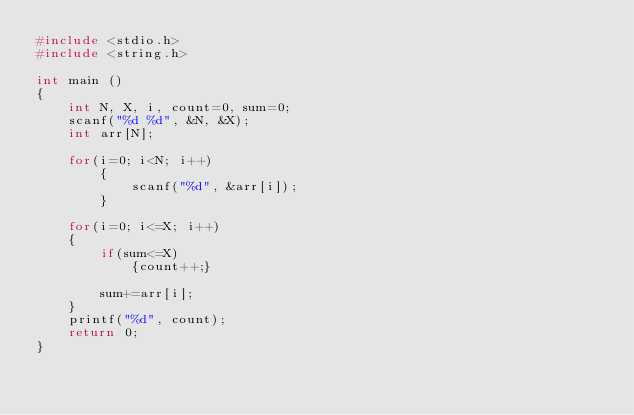Convert code to text. <code><loc_0><loc_0><loc_500><loc_500><_C_>#include <stdio.h>
#include <string.h>

int main ()
{
    int N, X, i, count=0, sum=0;
    scanf("%d %d", &N, &X);
    int arr[N];

    for(i=0; i<N; i++)
        {
            scanf("%d", &arr[i]);
        }

    for(i=0; i<=X; i++)
    {
        if(sum<=X)
            {count++;}

        sum+=arr[i];
    }
    printf("%d", count);
    return 0;
}
</code> 